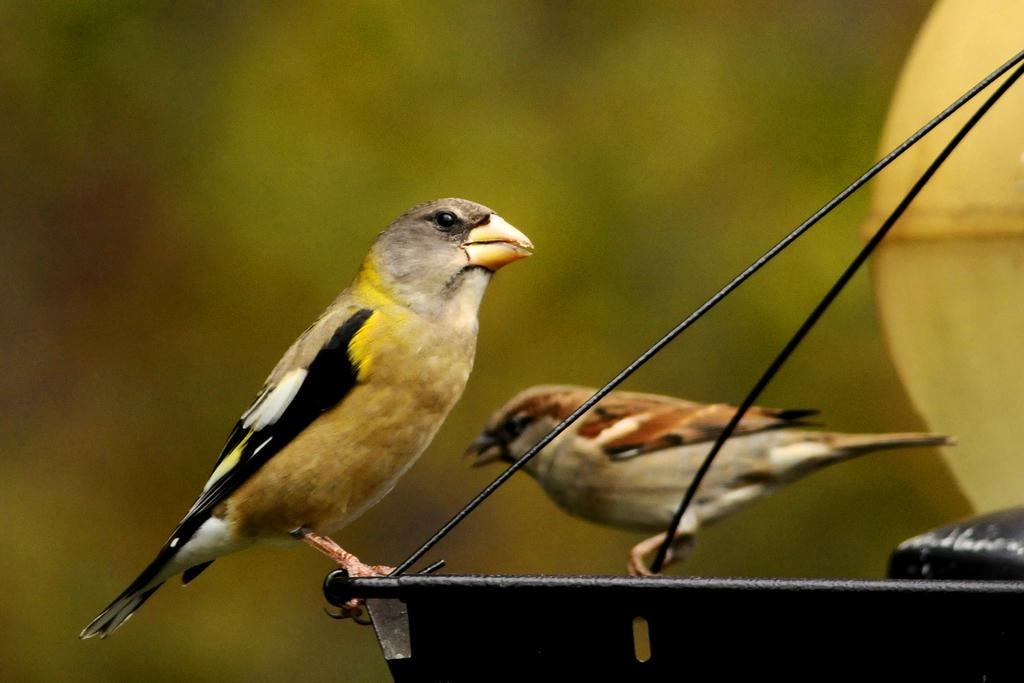How many birds can be seen in the image? There are two birds in the image. What are the birds standing on? The birds are standing on a metal object. What is located on the right side of the image? There is an object on the right side of the image. Can you describe the background of the image? The background of the image is blurry. What type of produce is being harvested by the birds in the image? There is no produce present in the image, and the birds are not depicted as harvesting anything. 